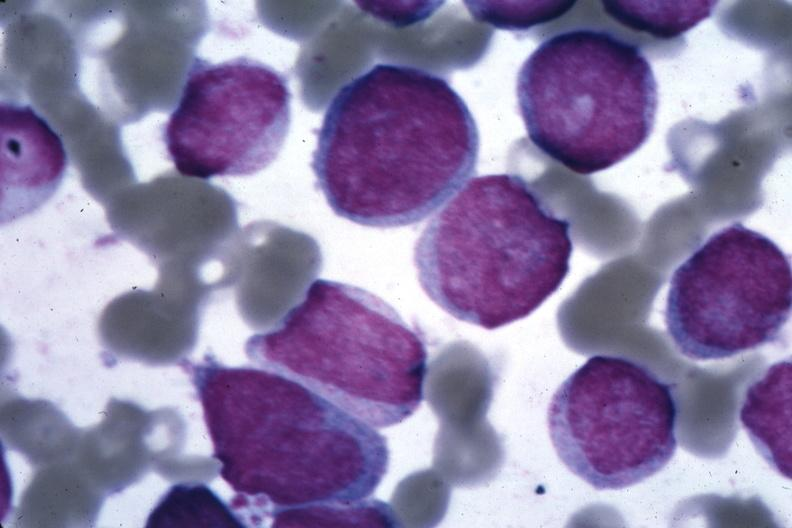what is present?
Answer the question using a single word or phrase. Hematologic 